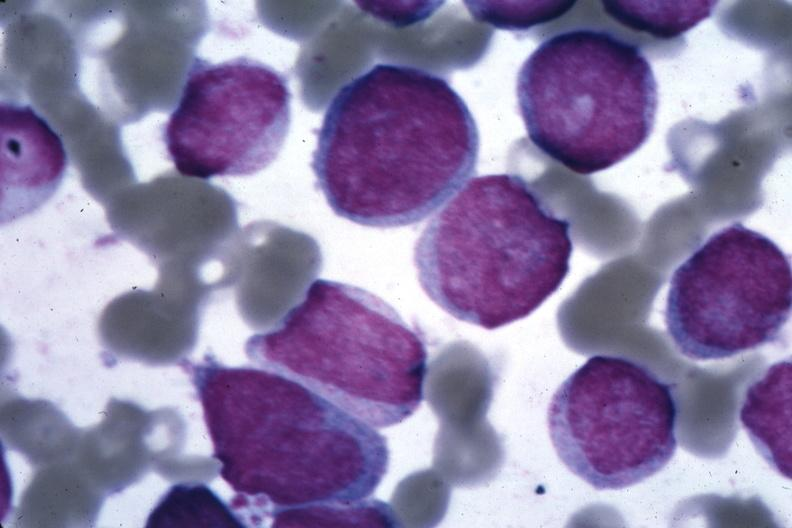what is present?
Answer the question using a single word or phrase. Hematologic 